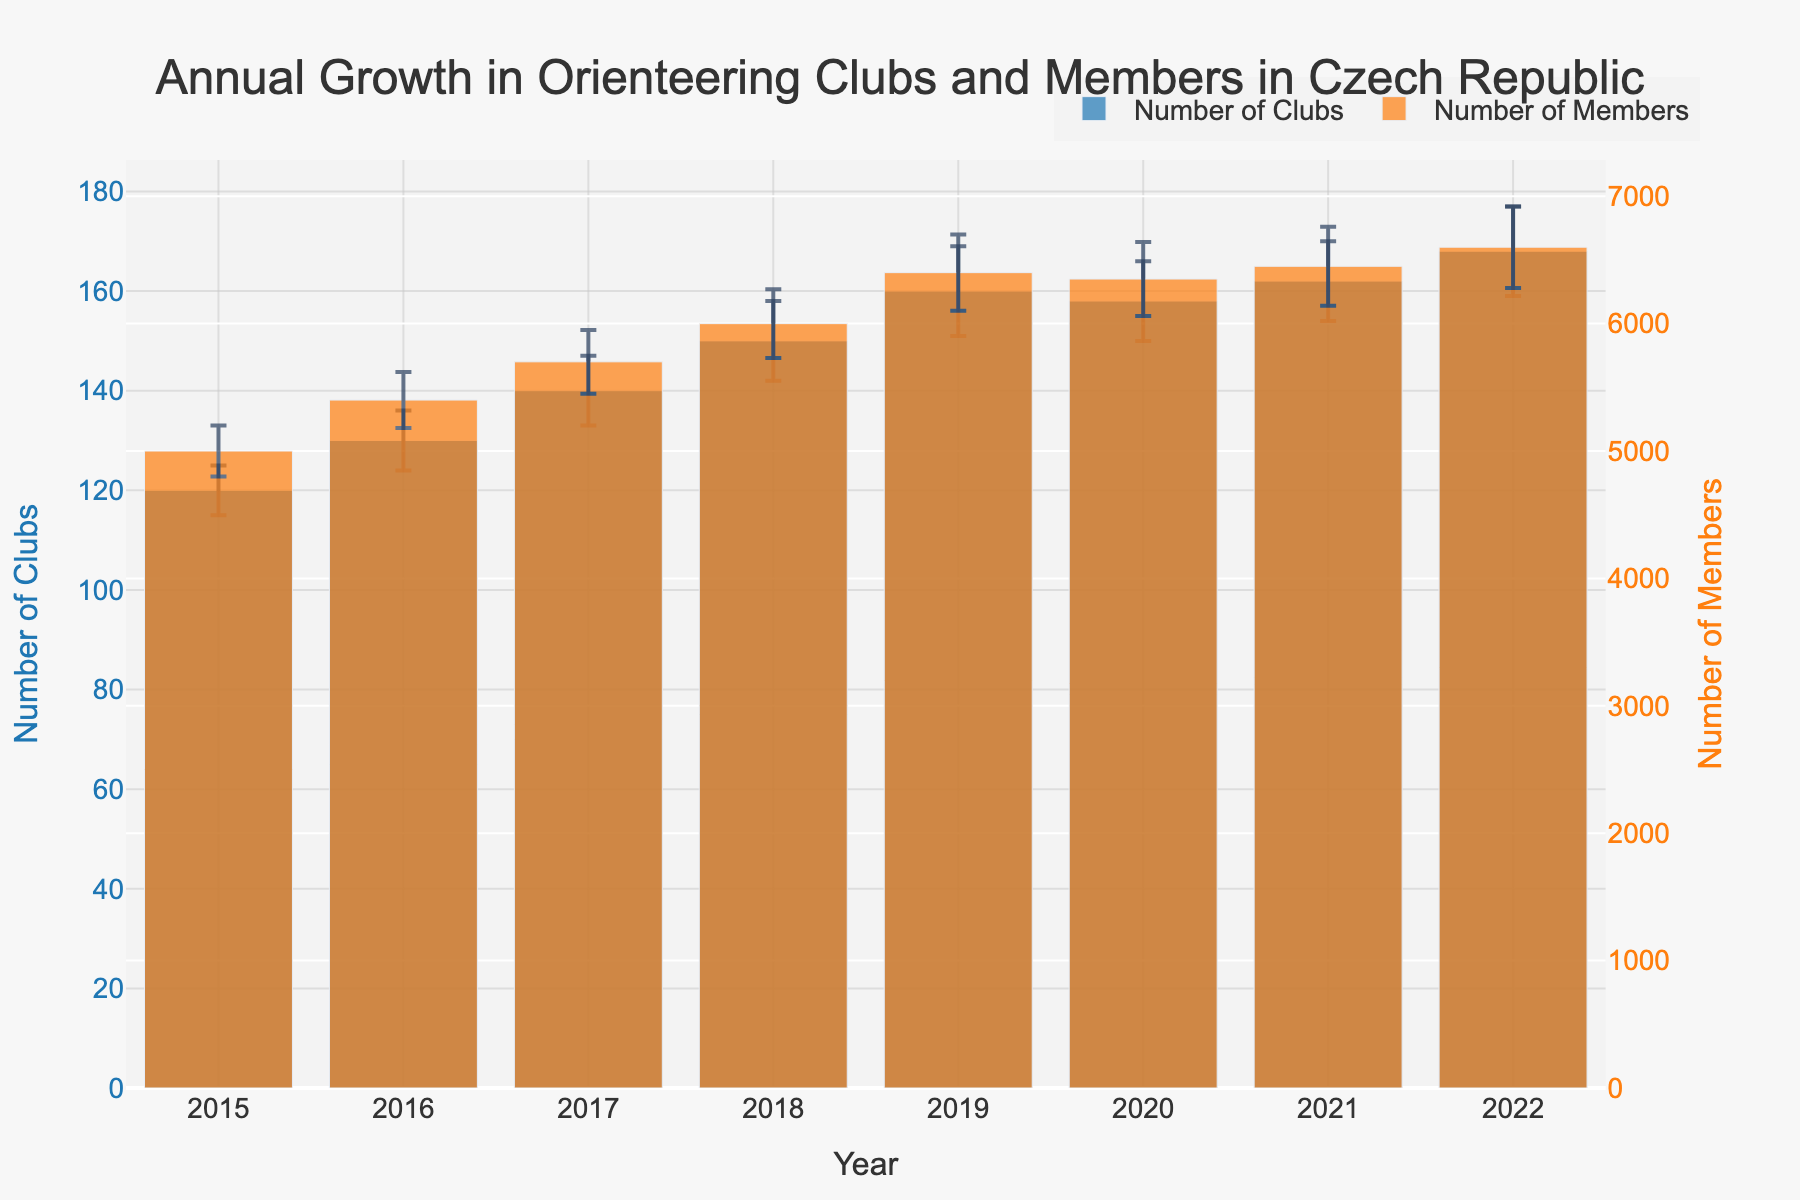What is the title of the figure? The title is located at the top of the figure in a larger font size, providing an overview of the data being visualized. The text is centered and reads 'Annual Growth in Orienteering Clubs and Members in Czech Republic'.
Answer: Annual Growth in Orienteering Clubs and Members in Czech Republic How many years are presented in the figure? The x-axis represents the years, with tick marks and labels for each year. By counting the labels, we find that the figure includes data from 8 different years (2015-2022).
Answer: 8 What is the trend in the number of clubs from 2015 to 2022? The bars for the 'Number of Clubs' start at a value in 2015 and generally increase over the years, indicating an upward trend. However, there is a slight decrease between 2019 and 2020, followed by an increase again.
Answer: Increasing with a slight dip in 2020 Which year has the highest number of members? The height of the orange bars represents the 'Number of Members'. The tallest orange bar corresponds to the year 2022, indicating it has the highest number of members.
Answer: 2022 How much did the number of clubs change between 2019 and 2020? In 2019, the number of clubs is represented by a blue bar of height 160. In 2020, the height of the blue bar is 158. The change is 160 - 158 = 2.
Answer: Decreased by 2 What is the average number of members in the given years? Summing the values of the 'Number of Members' for all years and dividing by the number of years: (5000 + 5400 + 5700 + 6000 + 6400 + 6350 + 6450 + 6600) / 8 = 5993.75.
Answer: 5993.75 Between which years did the number of clubs increase the most? By calculating the difference for each consecutive pair of years and comparing them, the biggest increase is from 2017 to 2018: 150 - 140 = 10.
Answer: 2017 to 2018 What error was associated with the number of members in 2021? The error bars associated with each year indicate the uncertainty. For 2021, the 'Number of Members' has an error of 310, as shown by the height of the error bar.
Answer: 310 Compare the total errors for 'Number of Clubs' and 'Number of Members' in 2022. Which is greater? The error for 'Number of Clubs' in 2022 is 9, and for 'Number of Members' it's 320. Comparing these values, the error for 'Number of Members' is greater.
Answer: Number of Members In which year was the increase in the number of members smallest compared to the previous year? By comparing the differences in 'Number of Members' year over year, the smallest increase is between 2020 and 2021: 6450 - 6350 = 100.
Answer: 2020 to 2021 